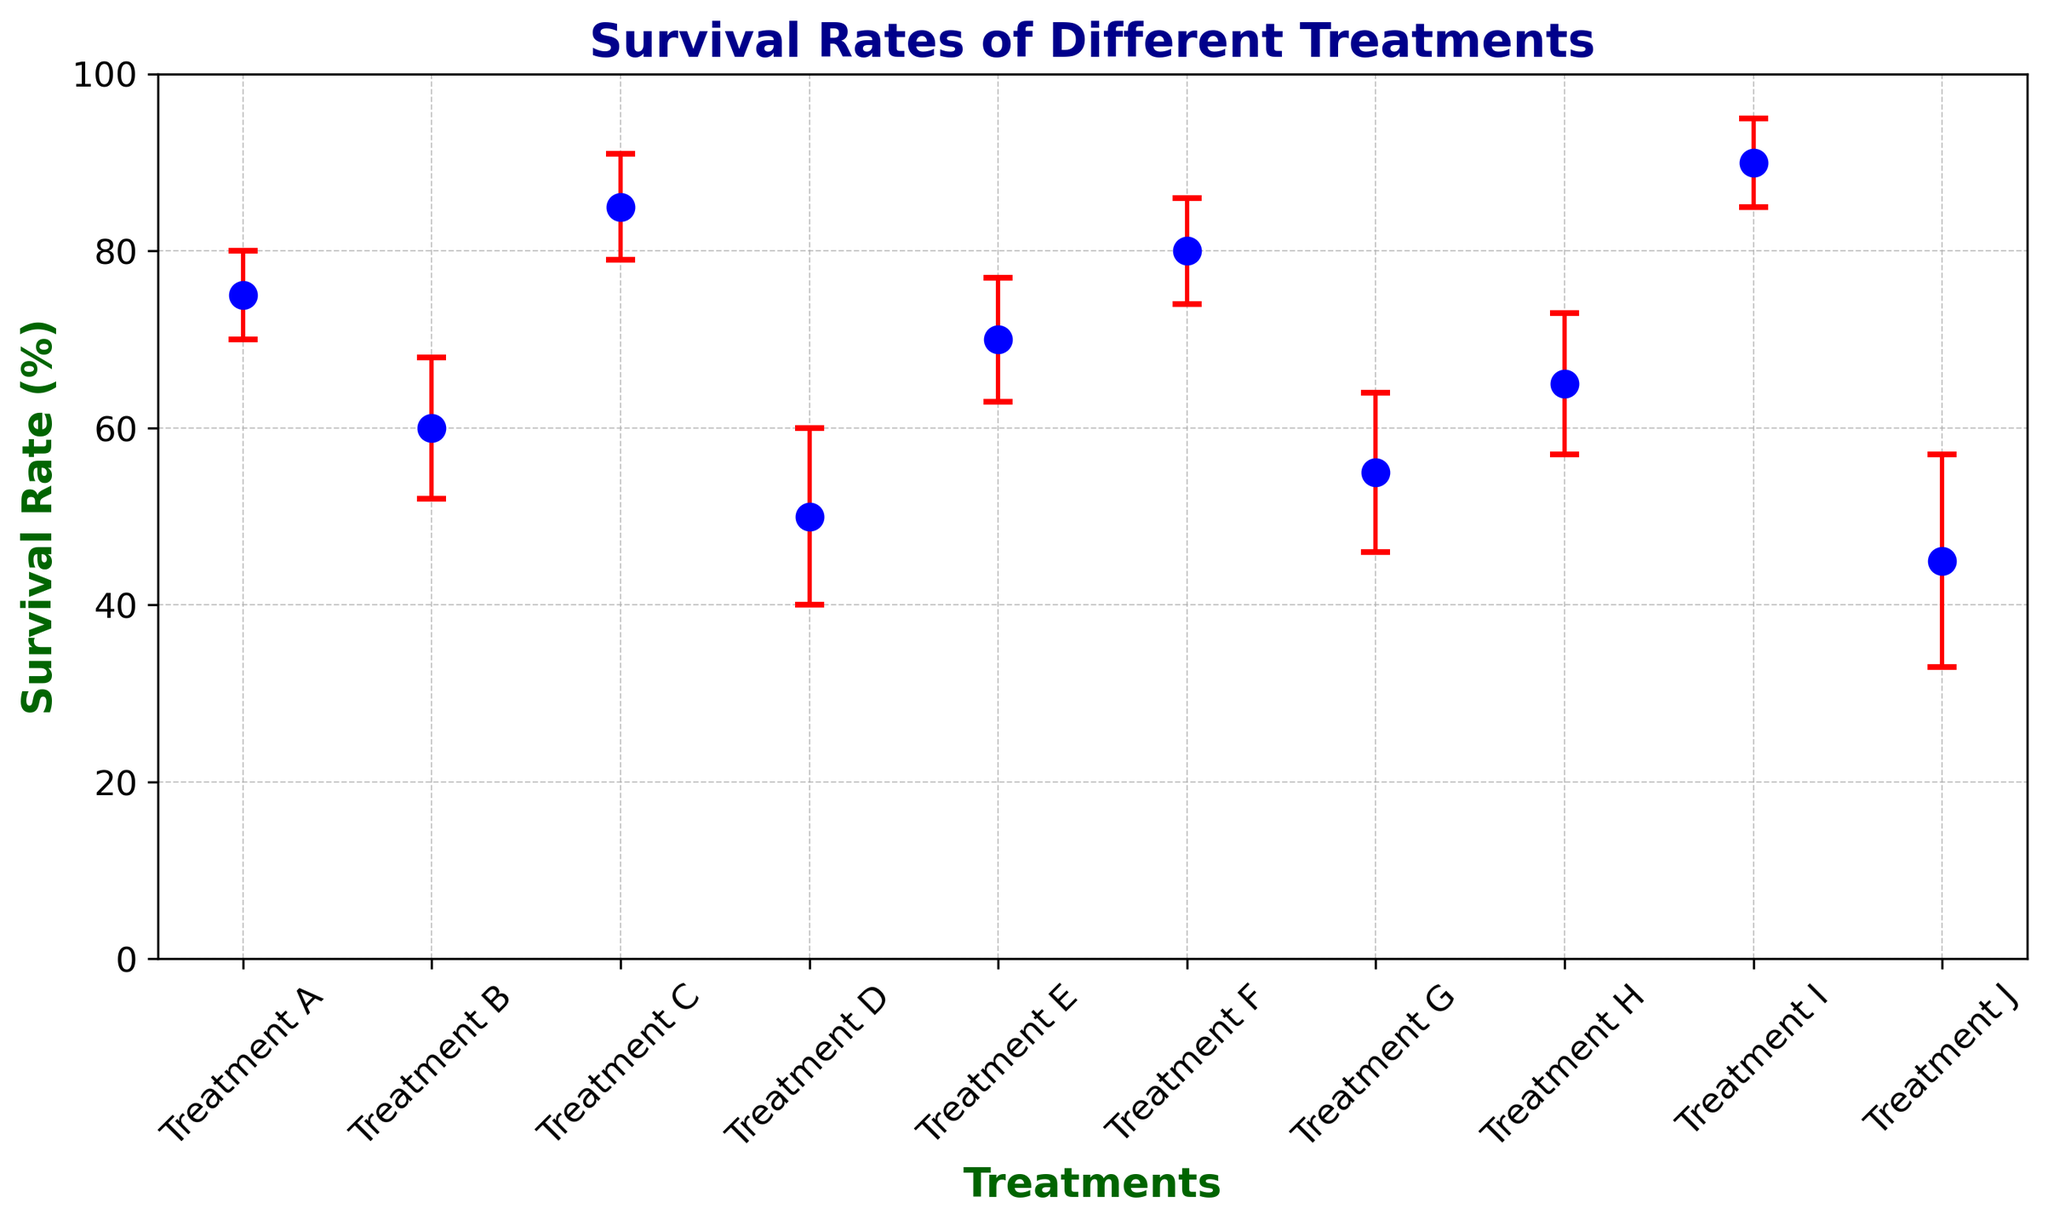What's the treatment with the highest survival rate? The figure shows survival rates for different treatments. Find the highest mark and its corresponding treatment. Treatment I has the highest survival rate at 90%.
Answer: Treatment I Which treatments have survival rates lower than 60%? Locate the treatments with survival rates below 60% by checking their heights on the y-axis. Treatments D, G, and J have survival rates of 50%, 55%, and 45% respectively.
Answer: Treatments D, G, J What is the difference in survival rates between Treatment A and Treatment J? Treatment A has a survival rate of 75%, and Treatment J has a survival rate of 45%. The difference is 75% - 45% = 30%.
Answer: 30% Which treatment has the highest uncertainty? Compare the error bars of each treatment to determine which one is the largest. Treatment J has the highest uncertainty at 12%.
Answer: Treatment J Calculate the average survival rate of the top 3 treatments. The top 3 survival rates are Treatment I (90%), Treatment C (85%), and Treatment F (80%). The average is (90 + 85 + 80)/3 = 85%.
Answer: 85% Is there any treatment with a survival rate of exactly 70%? Scan the figure for a treatment that has 70% survival rate. Treatment E has a survival rate of exactly 70%.
Answer: Treatment E How many treatments have an uncertainty of 8%? Count the number of treatments with error bars reflecting an 8% uncertainty. Treatments B and H have an uncertainty of 8%.
Answer: 2 treatments Which treatment has the second highest survival rate and what is its value? Identify the highest survival rate first (Treatment I with 90%) and then find the next highest (Treatment C with 85%).
Answer: Treatment C, 85% What is the median survival rate of the treatments? Arrange the survival rates in numerical order: 45%, 50%, 55%, 60%, 65%, 70%, 75%, 80%, 85%, 90%. The median value, or the middle value in the ordered list, is the average of the 5th and 6th values: (65 + 70)/2 = 67.5%.
Answer: 67.5% Compare the survival rates of Treatment B and Treatment D. Which one is higher? Check the figure to see that Treatment B has a survival rate of 60%, and Treatment D has a survival rate of 50%. Thus, Treatment B has a higher survival rate.
Answer: Treatment B 